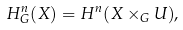Convert formula to latex. <formula><loc_0><loc_0><loc_500><loc_500>H _ { G } ^ { n } ( X ) = H ^ { n } ( X \times _ { G } U ) ,</formula> 